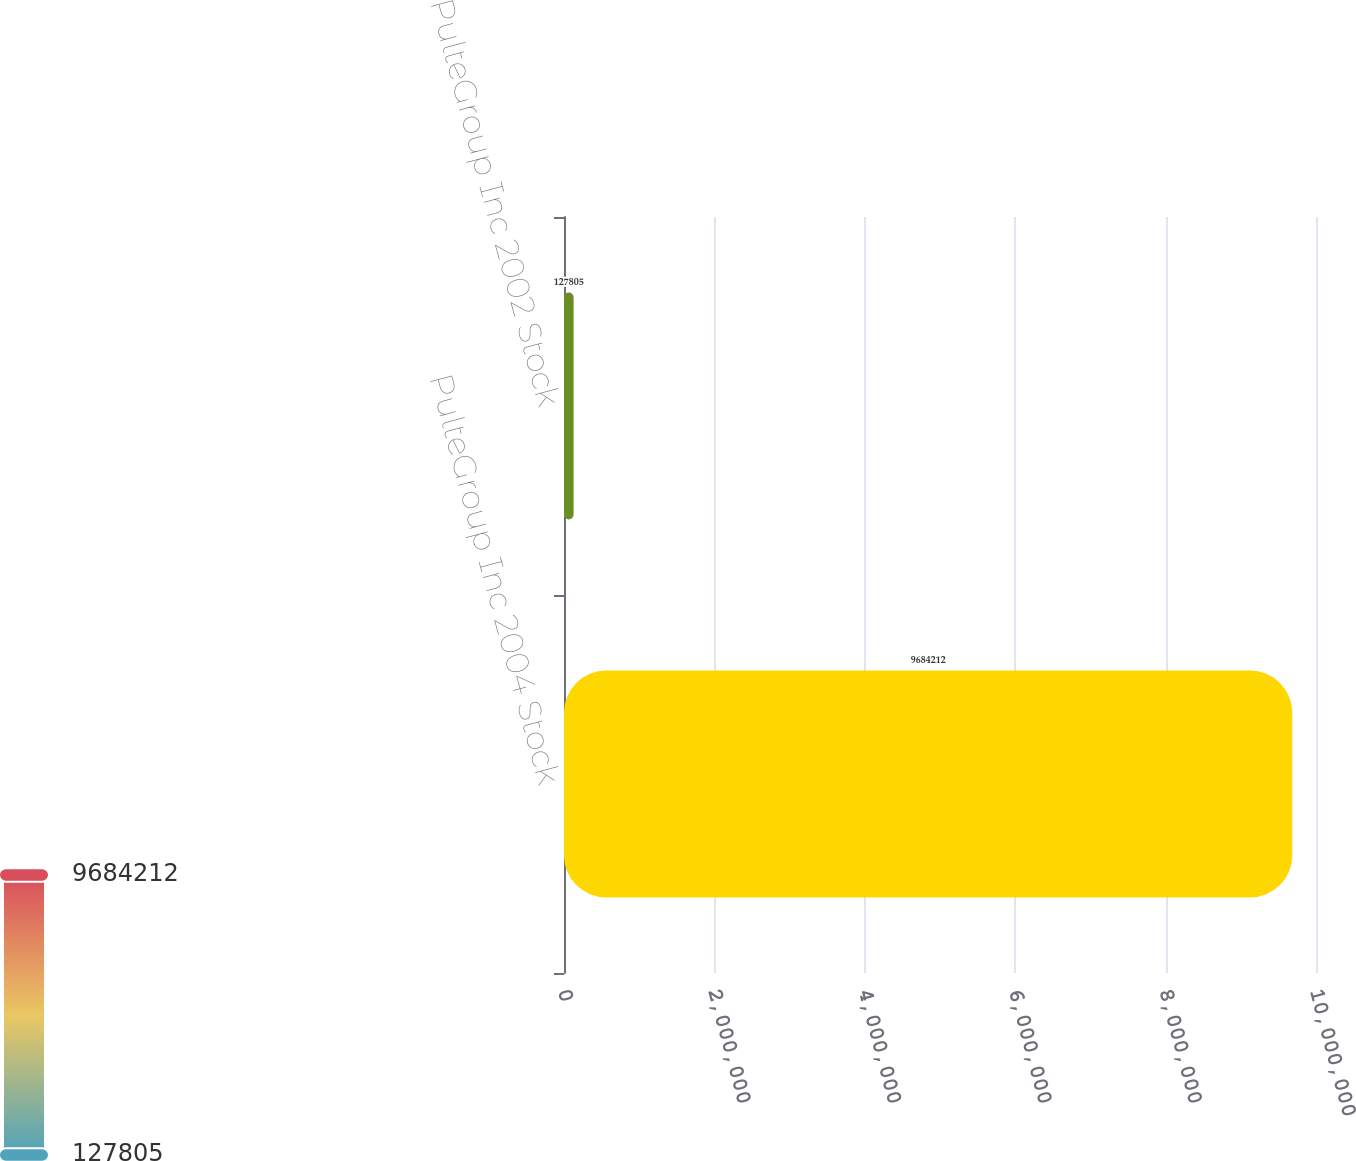Convert chart to OTSL. <chart><loc_0><loc_0><loc_500><loc_500><bar_chart><fcel>PulteGroup Inc 2004 Stock<fcel>PulteGroup Inc 2002 Stock<nl><fcel>9.68421e+06<fcel>127805<nl></chart> 